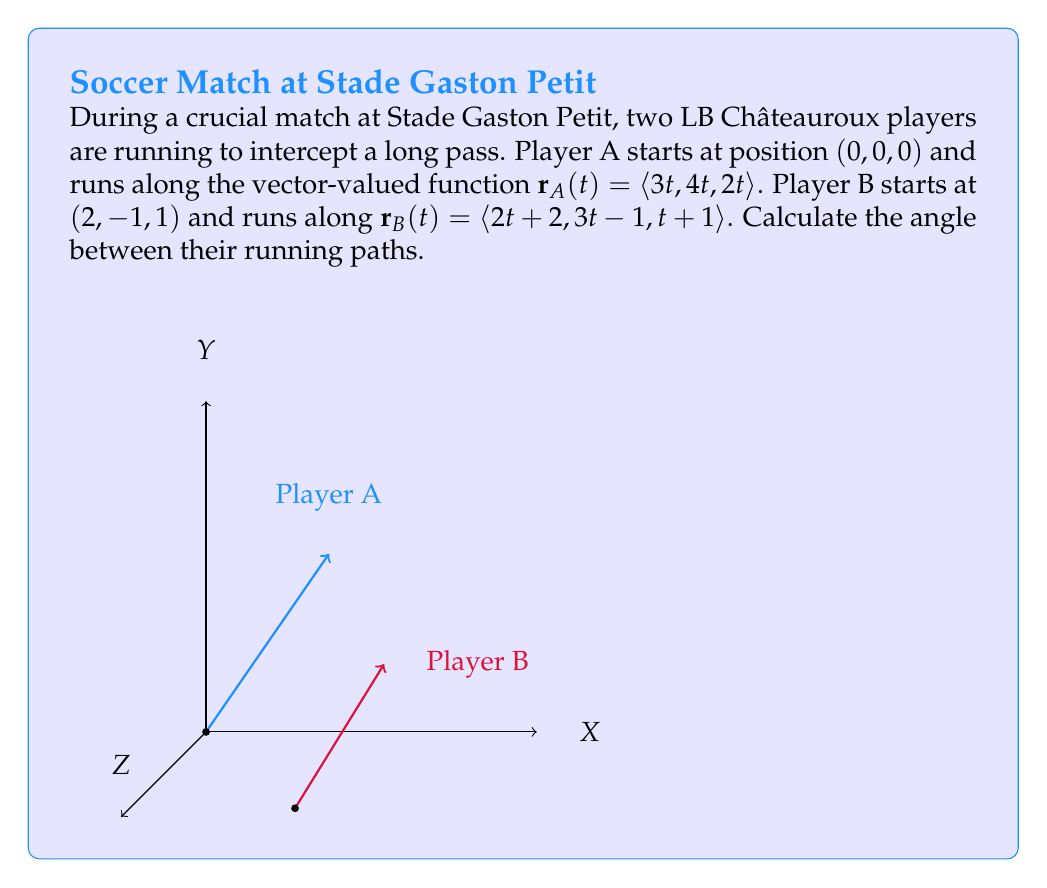What is the answer to this math problem? To find the angle between the players' running paths, we need to use the dot product formula:

$$\cos \theta = \frac{\mathbf{v}_1 \cdot \mathbf{v}_2}{|\mathbf{v}_1||\mathbf{v}_2|}$$

Where $\mathbf{v}_1$ and $\mathbf{v}_2$ are the direction vectors of the players' paths.

Step 1: Identify the direction vectors
- For Player A: $\mathbf{v}_A = \langle 3, 4, 2 \rangle$
- For Player B: $\mathbf{v}_B = \langle 2, 3, 1 \rangle$

Step 2: Calculate the dot product $\mathbf{v}_A \cdot \mathbf{v}_B$
$$\mathbf{v}_A \cdot \mathbf{v}_B = 3(2) + 4(3) + 2(1) = 6 + 12 + 2 = 20$$

Step 3: Calculate the magnitudes
$$|\mathbf{v}_A| = \sqrt{3^2 + 4^2 + 2^2} = \sqrt{29}$$
$$|\mathbf{v}_B| = \sqrt{2^2 + 3^2 + 1^2} = \sqrt{14}$$

Step 4: Apply the dot product formula
$$\cos \theta = \frac{20}{\sqrt{29}\sqrt{14}}$$

Step 5: Solve for $\theta$
$$\theta = \arccos\left(\frac{20}{\sqrt{29}\sqrt{14}}\right)$$

Step 6: Calculate the result (in radians)
$$\theta \approx 0.2257 \text{ radians}$$

Step 7: Convert to degrees
$$\theta \approx 12.93°$$
Answer: $12.93°$ 